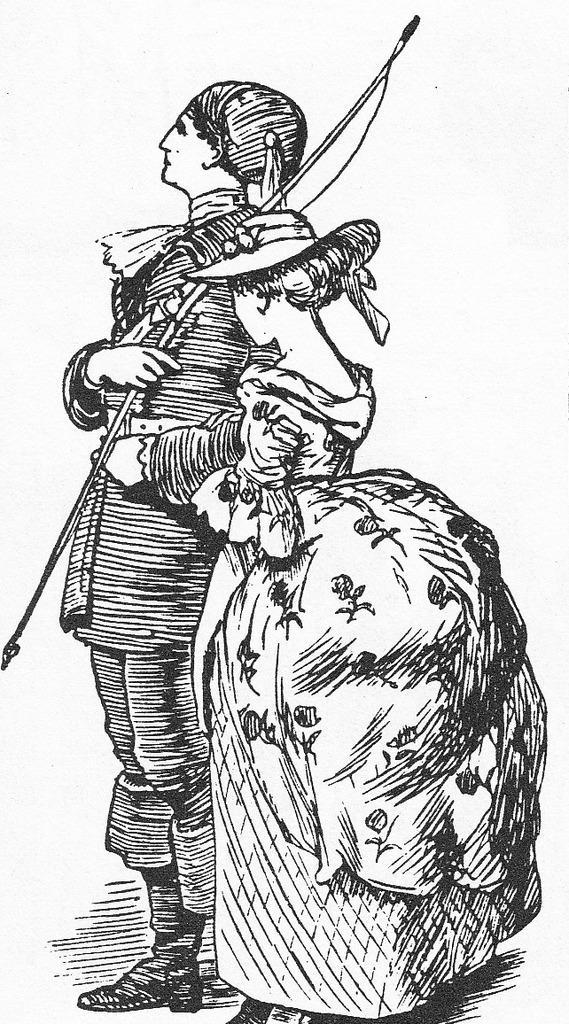What is the main subject in the image? There is a man standing in the image. Can you describe any other objects or elements in the image? There is an object in the image. What type of fire can be seen in the wilderness in the image? There is no fire or wilderness present in the image; it only features a man standing and an object. 